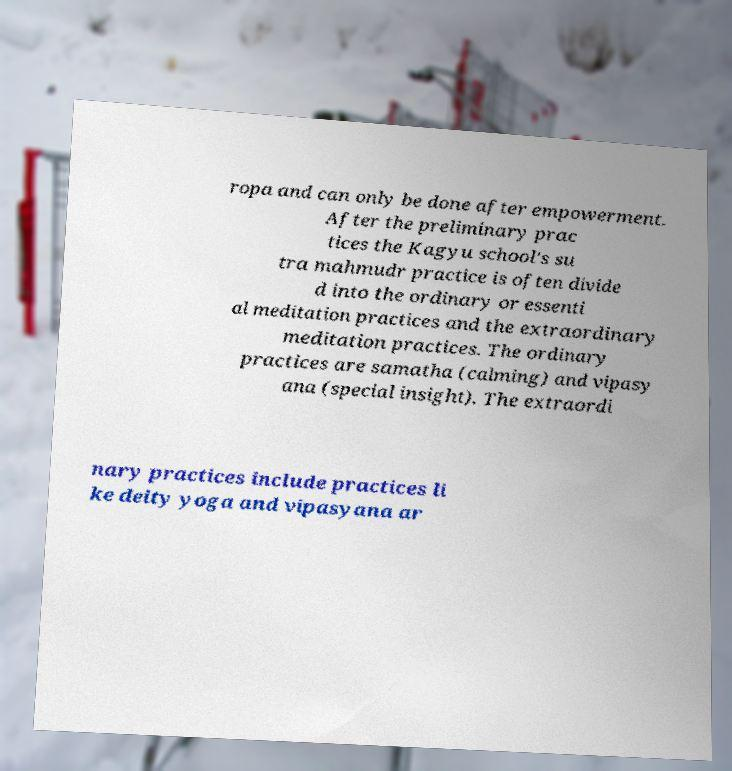Can you read and provide the text displayed in the image?This photo seems to have some interesting text. Can you extract and type it out for me? ropa and can only be done after empowerment. After the preliminary prac tices the Kagyu school's su tra mahmudr practice is often divide d into the ordinary or essenti al meditation practices and the extraordinary meditation practices. The ordinary practices are samatha (calming) and vipasy ana (special insight). The extraordi nary practices include practices li ke deity yoga and vipasyana ar 